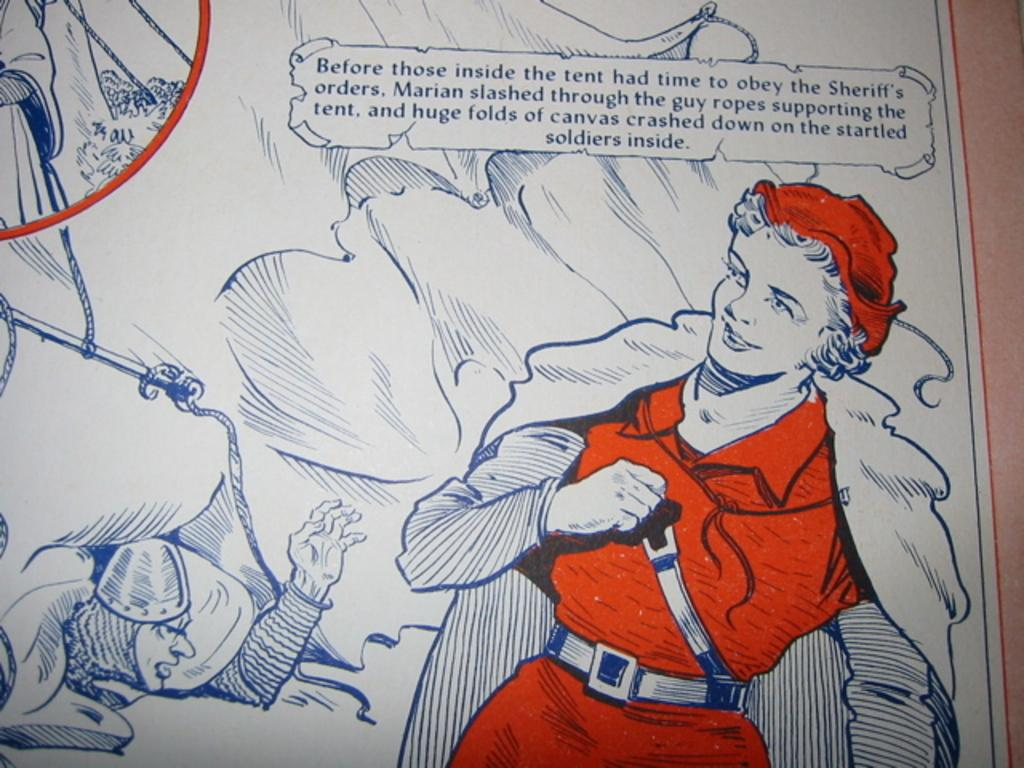<image>
Render a clear and concise summary of the photo. A passage in a book is about cutting open a soldiers tent. 